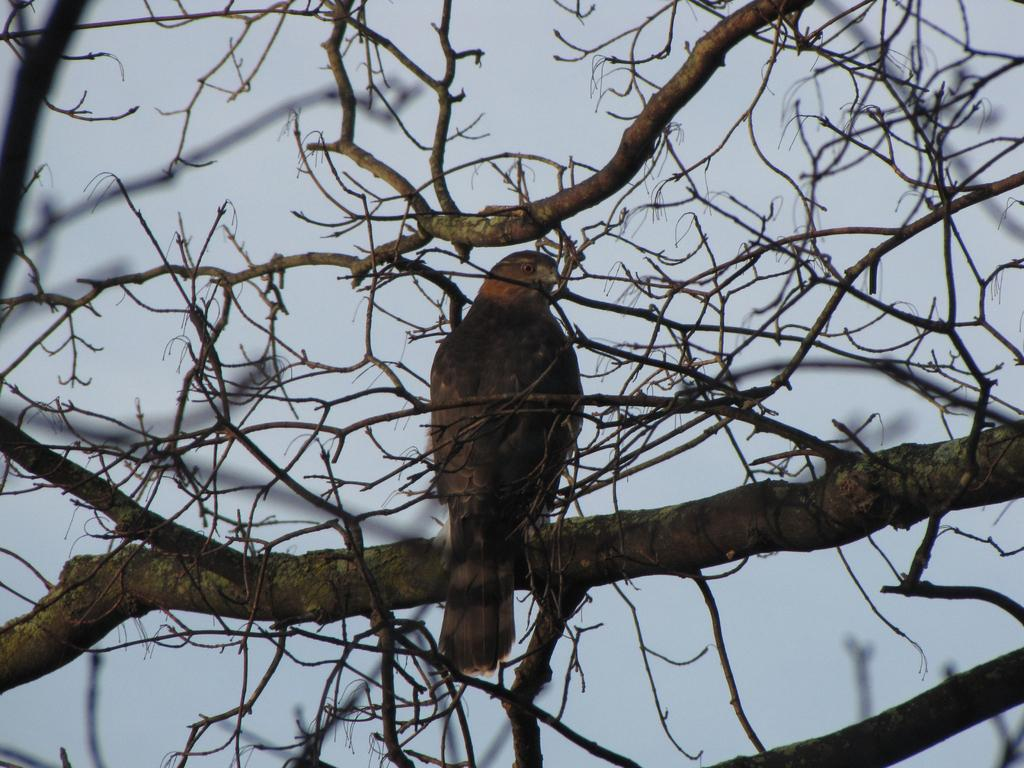What is the main subject in the foreground of the image? There is a bird in the foreground of the image. Where is the bird located? The bird is on the branch of a tree. What can be seen in the background of the image? The sky is visible in the background of the image. What type of error can be seen in the bird's voice in the image? There is no reference to a bird's voice or any errors in the image; it simply shows a bird on a tree branch. 